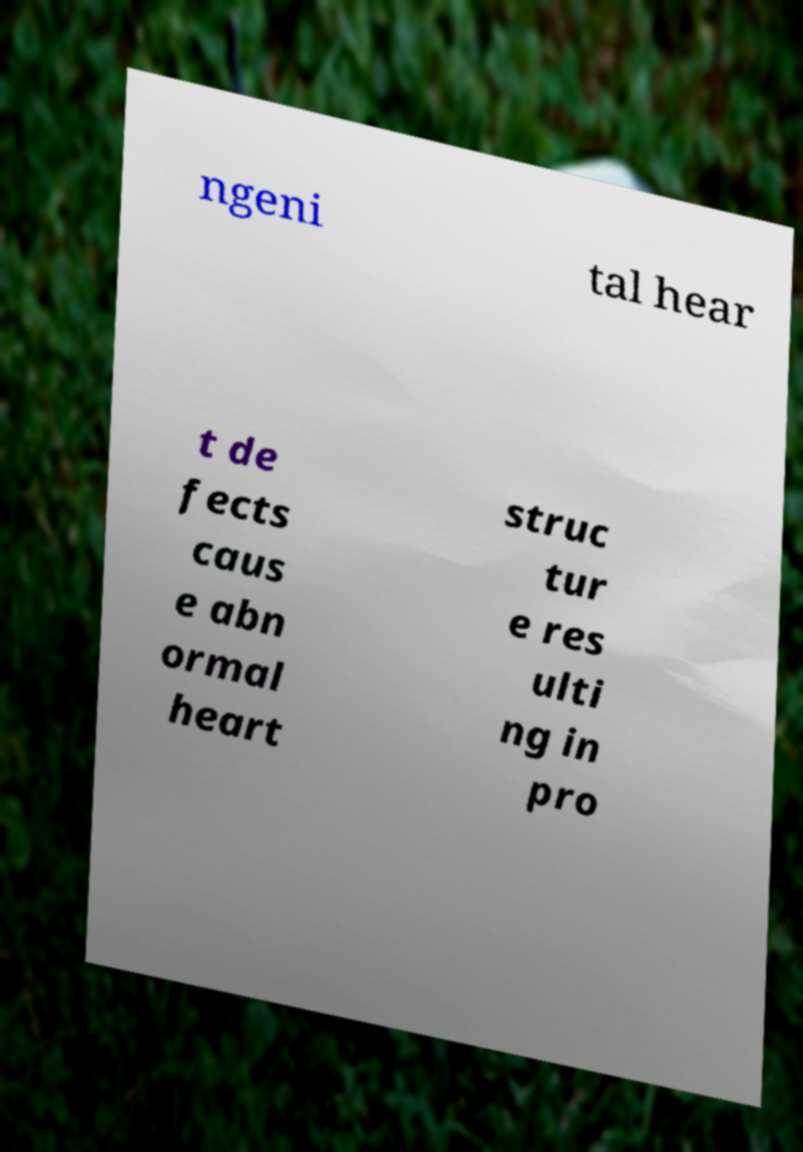Can you read and provide the text displayed in the image?This photo seems to have some interesting text. Can you extract and type it out for me? ngeni tal hear t de fects caus e abn ormal heart struc tur e res ulti ng in pro 